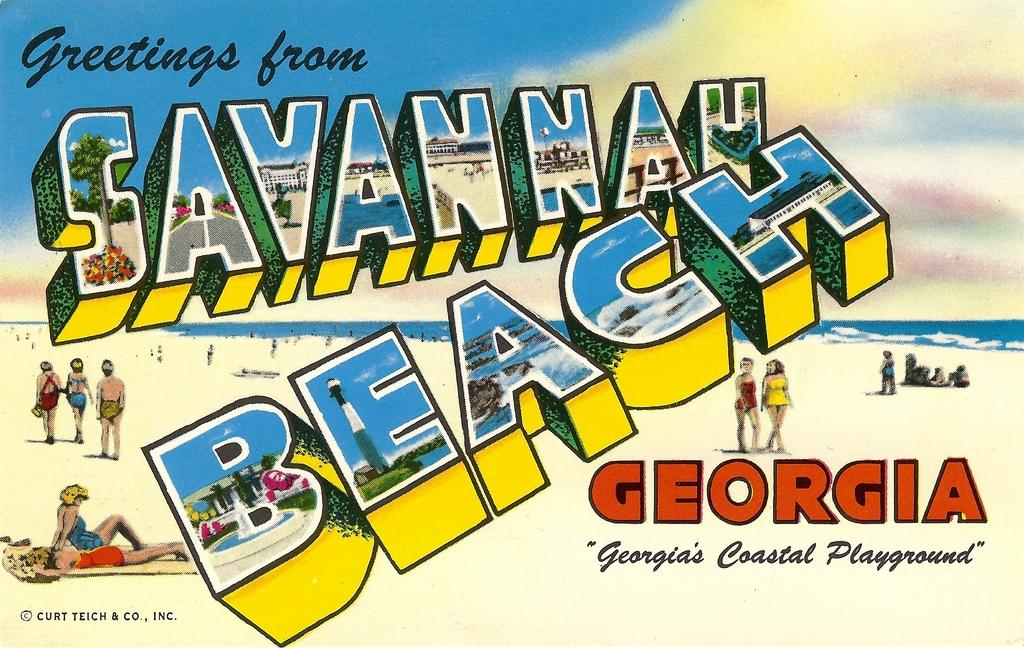<image>
Provide a brief description of the given image. A postcard says "Greetings From Savannah Beach, Georgia. 